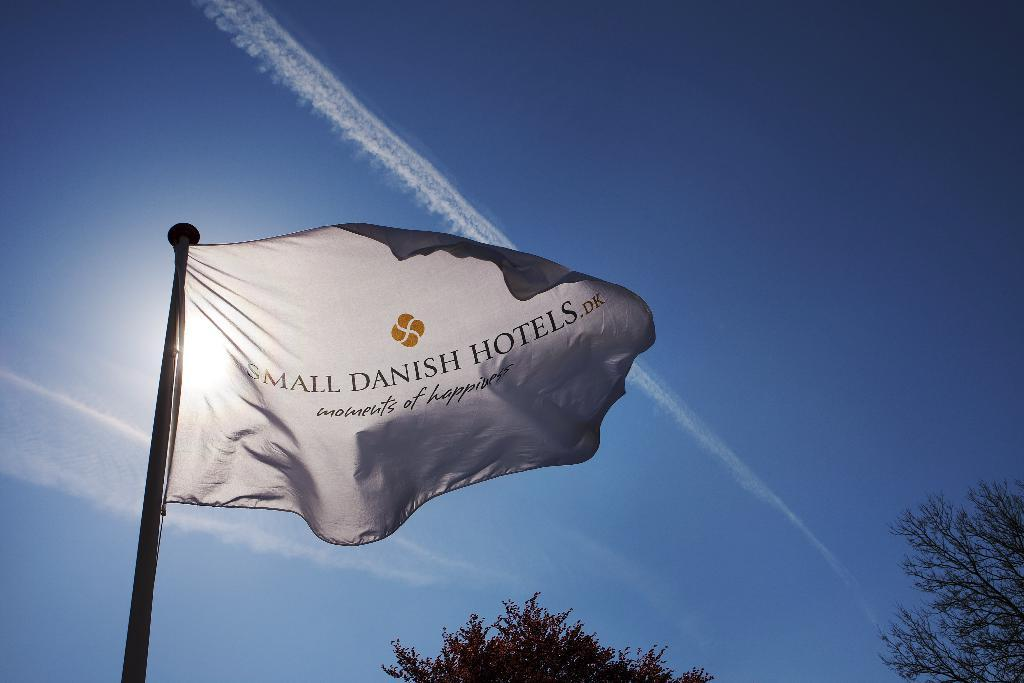What is the main object in the image? There is a flag in the image. What can be seen in the background of the image? There are trees and clouds in the background of the image. How many bananas are hanging from the tiger in the cave in the image? There is no tiger, cave, or bananas present in the image. The image only features a flag and background elements of trees and clouds. 